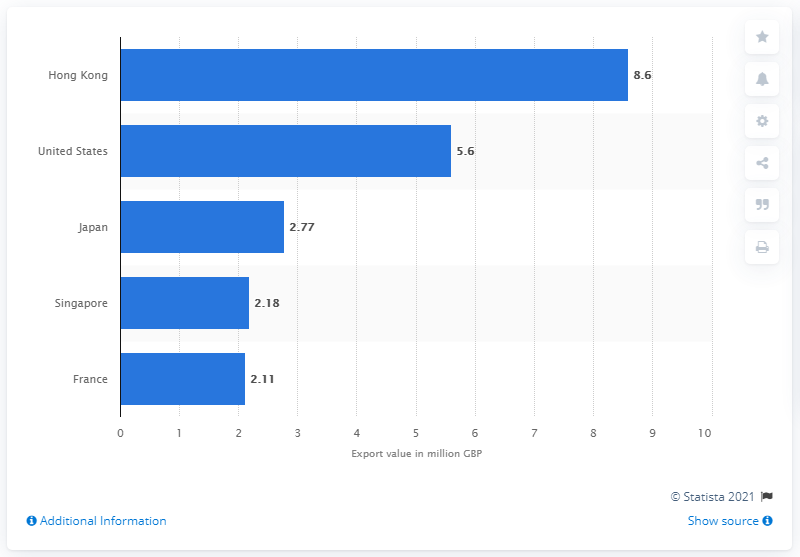Highlight a few significant elements in this photo. Hong Kong's champagne export value is 8.6 million. The United States exported $5.6 billion worth of champagne in the past year. 